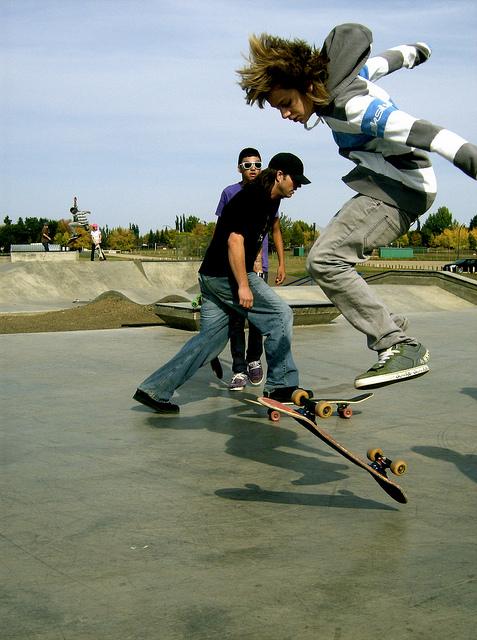What activity are these kids performing?
Write a very short answer. Skateboarding. Why is the young man hang in mid air?
Concise answer only. Jumping. How many skateboards are there?
Short answer required. 3. How many skateboards do you see?
Quick response, please. 2. What color is the child's cap?
Quick response, please. Black. What color are the wheels?
Quick response, please. Yellow. How many feet does the skateboard have touching the skateboard?
Quick response, please. 0. What color is the man's hair?
Concise answer only. Brown. What is the man doing with his skateboard?
Concise answer only. Trick. 